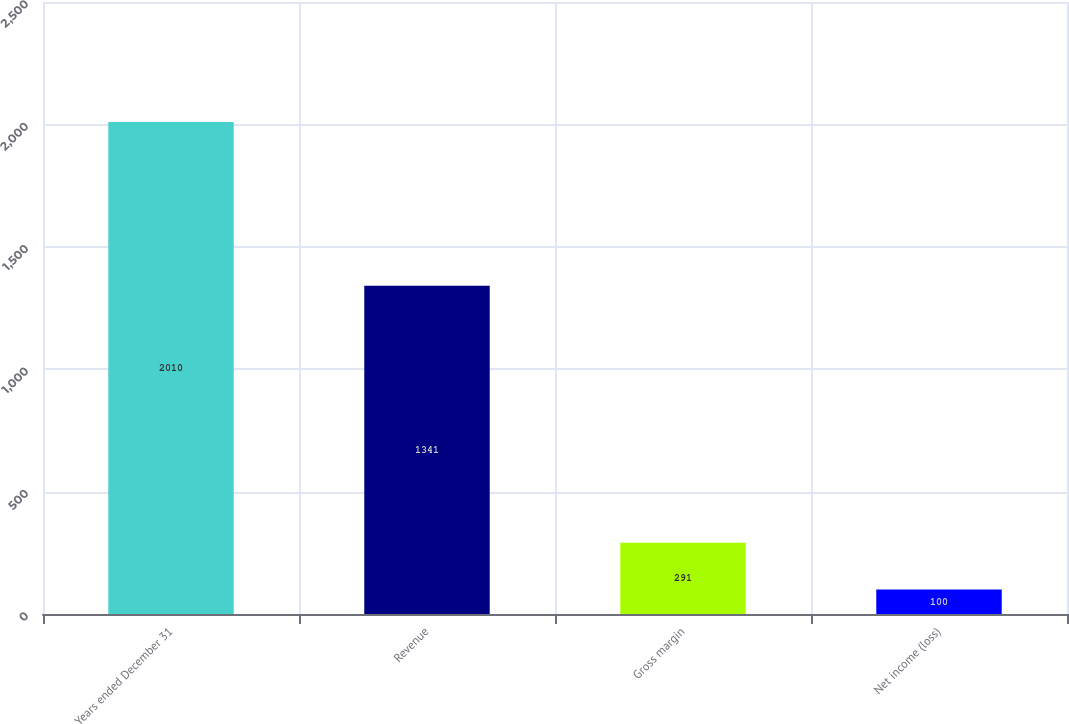Convert chart to OTSL. <chart><loc_0><loc_0><loc_500><loc_500><bar_chart><fcel>Years ended December 31<fcel>Revenue<fcel>Gross margin<fcel>Net income (loss)<nl><fcel>2010<fcel>1341<fcel>291<fcel>100<nl></chart> 